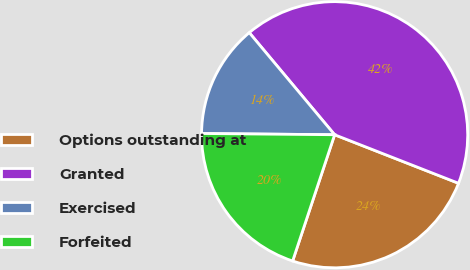Convert chart. <chart><loc_0><loc_0><loc_500><loc_500><pie_chart><fcel>Options outstanding at<fcel>Granted<fcel>Exercised<fcel>Forfeited<nl><fcel>24.17%<fcel>42.03%<fcel>13.77%<fcel>20.04%<nl></chart> 